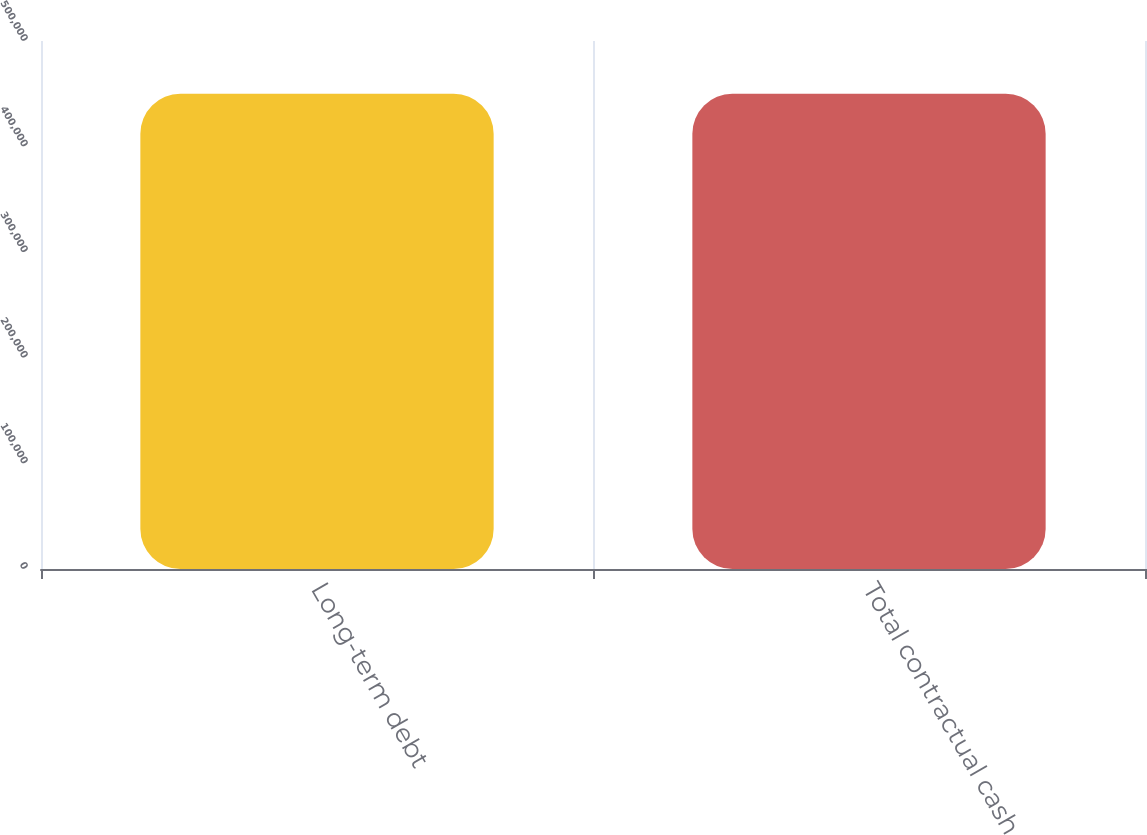Convert chart to OTSL. <chart><loc_0><loc_0><loc_500><loc_500><bar_chart><fcel>Long-term debt<fcel>Total contractual cash<nl><fcel>450000<fcel>450000<nl></chart> 